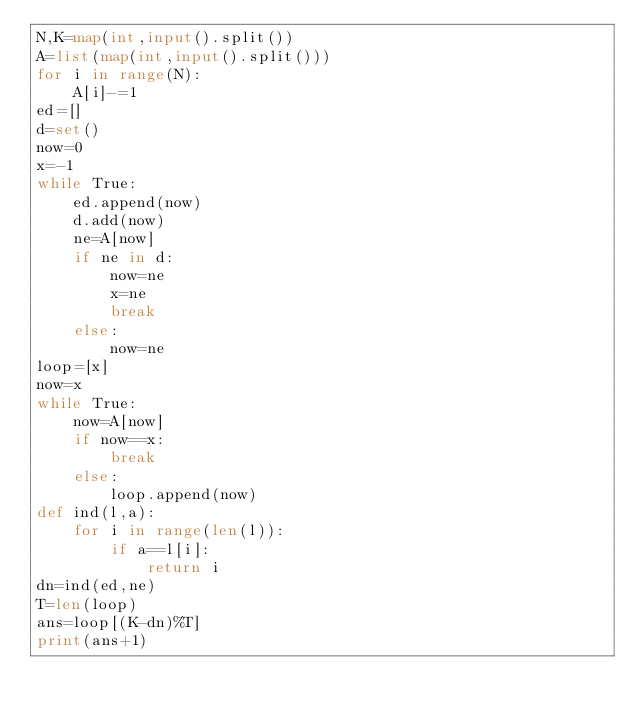<code> <loc_0><loc_0><loc_500><loc_500><_Python_>N,K=map(int,input().split())
A=list(map(int,input().split()))
for i in range(N):
    A[i]-=1
ed=[]
d=set()
now=0
x=-1
while True:
    ed.append(now)
    d.add(now)
    ne=A[now]
    if ne in d:
        now=ne
        x=ne
        break
    else:
        now=ne
loop=[x]
now=x
while True:
    now=A[now]
    if now==x:
        break
    else:
        loop.append(now)
def ind(l,a):
    for i in range(len(l)):
        if a==l[i]:
            return i
dn=ind(ed,ne)
T=len(loop)
ans=loop[(K-dn)%T]
print(ans+1)</code> 